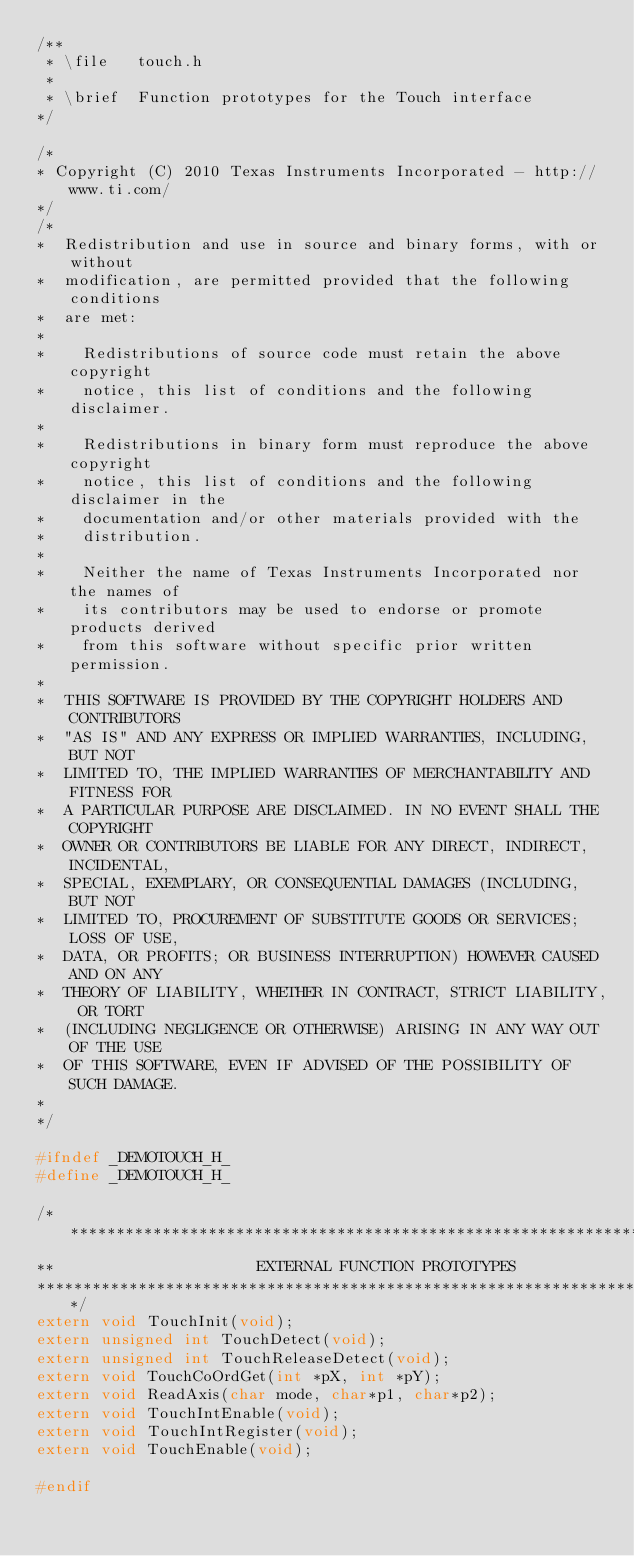Convert code to text. <code><loc_0><loc_0><loc_500><loc_500><_C_>/**
 * \file   touch.h
 *
 * \brief  Function prototypes for the Touch interface
*/

/*
* Copyright (C) 2010 Texas Instruments Incorporated - http://www.ti.com/
*/
/*
*  Redistribution and use in source and binary forms, with or without
*  modification, are permitted provided that the following conditions
*  are met:
*
*    Redistributions of source code must retain the above copyright
*    notice, this list of conditions and the following disclaimer.
*
*    Redistributions in binary form must reproduce the above copyright
*    notice, this list of conditions and the following disclaimer in the
*    documentation and/or other materials provided with the
*    distribution.
*
*    Neither the name of Texas Instruments Incorporated nor the names of
*    its contributors may be used to endorse or promote products derived
*    from this software without specific prior written permission.
*
*  THIS SOFTWARE IS PROVIDED BY THE COPYRIGHT HOLDERS AND CONTRIBUTORS
*  "AS IS" AND ANY EXPRESS OR IMPLIED WARRANTIES, INCLUDING, BUT NOT
*  LIMITED TO, THE IMPLIED WARRANTIES OF MERCHANTABILITY AND FITNESS FOR
*  A PARTICULAR PURPOSE ARE DISCLAIMED. IN NO EVENT SHALL THE COPYRIGHT
*  OWNER OR CONTRIBUTORS BE LIABLE FOR ANY DIRECT, INDIRECT, INCIDENTAL,
*  SPECIAL, EXEMPLARY, OR CONSEQUENTIAL DAMAGES (INCLUDING, BUT NOT
*  LIMITED TO, PROCUREMENT OF SUBSTITUTE GOODS OR SERVICES; LOSS OF USE,
*  DATA, OR PROFITS; OR BUSINESS INTERRUPTION) HOWEVER CAUSED AND ON ANY
*  THEORY OF LIABILITY, WHETHER IN CONTRACT, STRICT LIABILITY, OR TORT
*  (INCLUDING NEGLIGENCE OR OTHERWISE) ARISING IN ANY WAY OUT OF THE USE
*  OF THIS SOFTWARE, EVEN IF ADVISED OF THE POSSIBILITY OF SUCH DAMAGE.
*
*/

#ifndef _DEMOTOUCH_H_
#define _DEMOTOUCH_H_

/******************************************************************************
**                      EXTERNAL FUNCTION PROTOTYPES
*******************************************************************************/
extern void TouchInit(void);
extern unsigned int TouchDetect(void);
extern unsigned int TouchReleaseDetect(void);
extern void TouchCoOrdGet(int *pX, int *pY);
extern void ReadAxis(char mode, char*p1, char*p2);
extern void TouchIntEnable(void);
extern void TouchIntRegister(void);
extern void TouchEnable(void);

#endif
</code> 